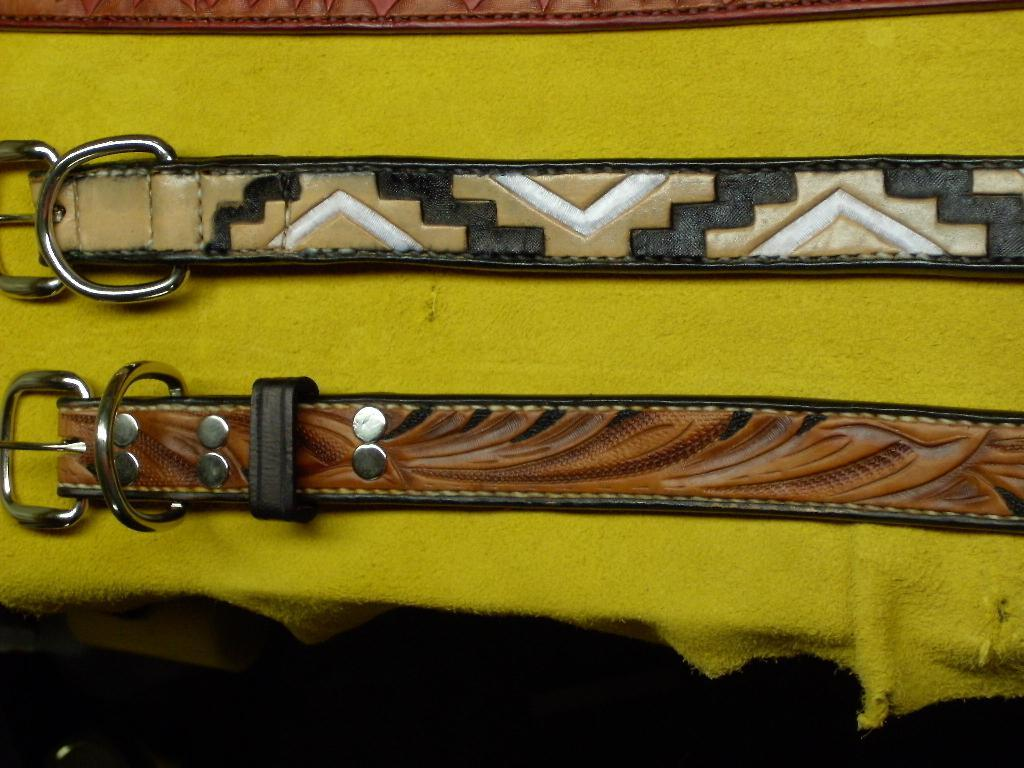What objects are on the table in the image? There are belts on a table in the image. What color is the cloth visible in the image? There is a yellow-colored cloth in the image. What type of insurance is being discussed in the image? There is no discussion of insurance in the image; it features belts on a table and a yellow-colored cloth. How many feet are visible in the image? There are no feet visible in the image. 